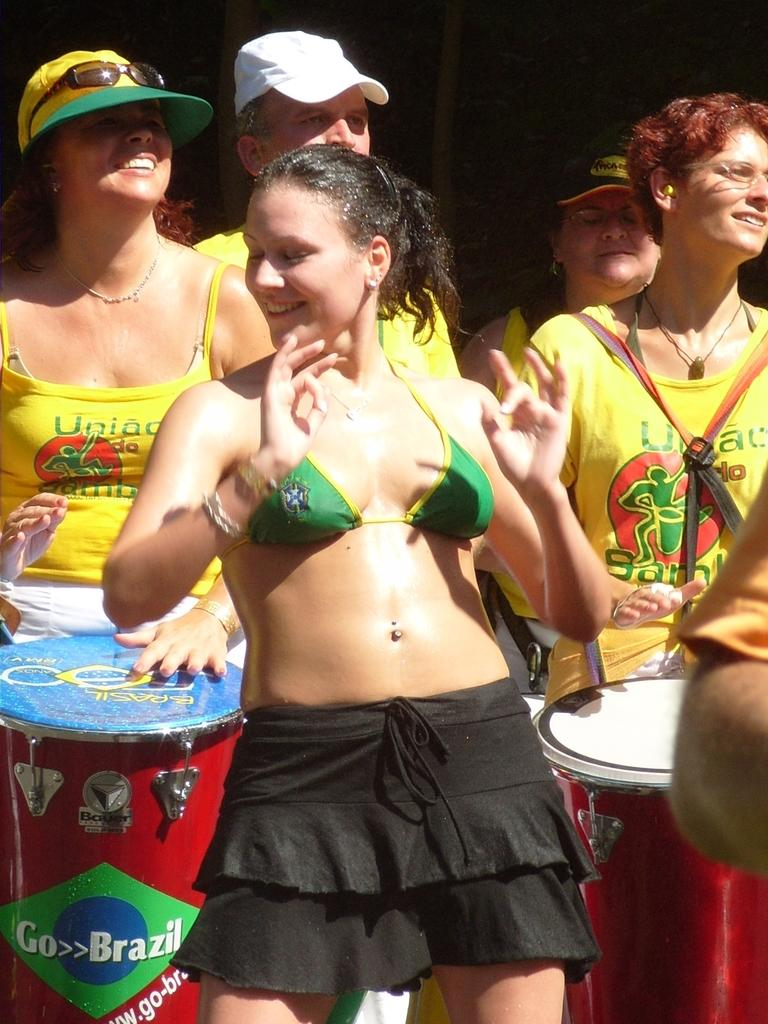How many people are in the image? There are people in the image, but the exact number is not specified. What are the people in the image doing? The people are standing and smiling. What objects are the people holding in the image? The people are holding drums. What type of tray is visible in the image? There is no tray present in the image. Is the ground on which the people are standing sloped or flat in the image? The information provided does not specify whether the ground is sloped or flat. 